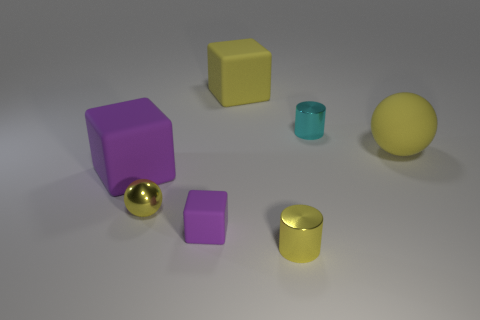Subtract all purple cubes. How many were subtracted if there are1purple cubes left? 1 Subtract all red cylinders. How many purple blocks are left? 2 Subtract all large matte blocks. How many blocks are left? 1 Add 2 purple metal spheres. How many objects exist? 9 Subtract all blocks. How many objects are left? 4 Subtract all tiny metallic objects. Subtract all large balls. How many objects are left? 3 Add 1 cyan cylinders. How many cyan cylinders are left? 2 Add 4 balls. How many balls exist? 6 Subtract 0 brown cubes. How many objects are left? 7 